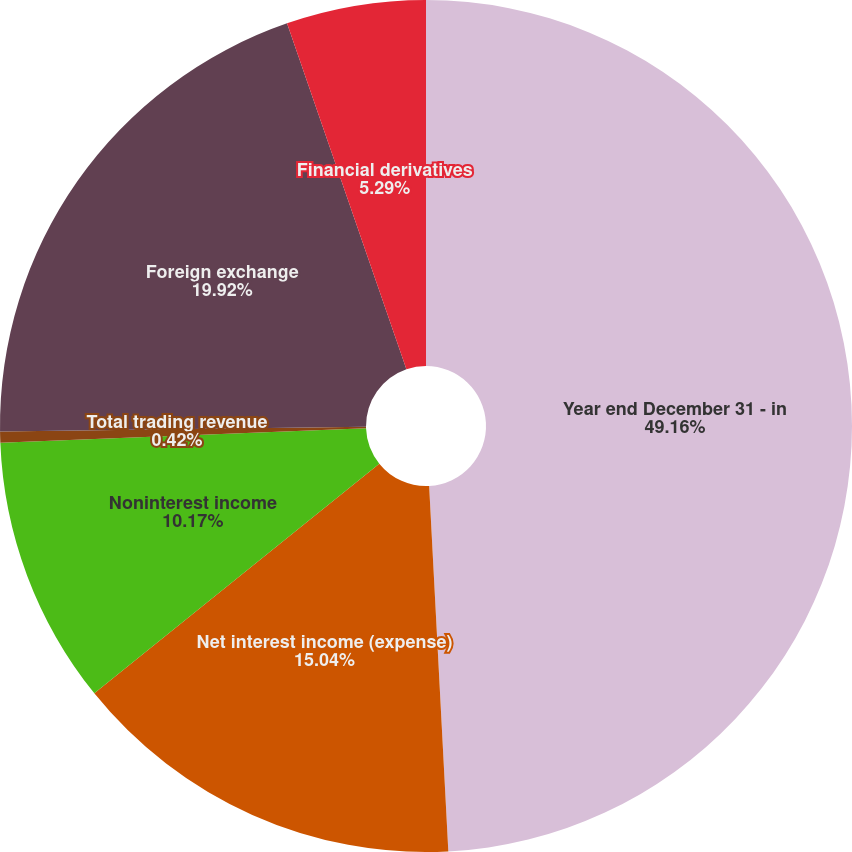Convert chart to OTSL. <chart><loc_0><loc_0><loc_500><loc_500><pie_chart><fcel>Year end December 31 - in<fcel>Net interest income (expense)<fcel>Noninterest income<fcel>Total trading revenue<fcel>Foreign exchange<fcel>Financial derivatives<nl><fcel>49.17%<fcel>15.04%<fcel>10.17%<fcel>0.42%<fcel>19.92%<fcel>5.29%<nl></chart> 